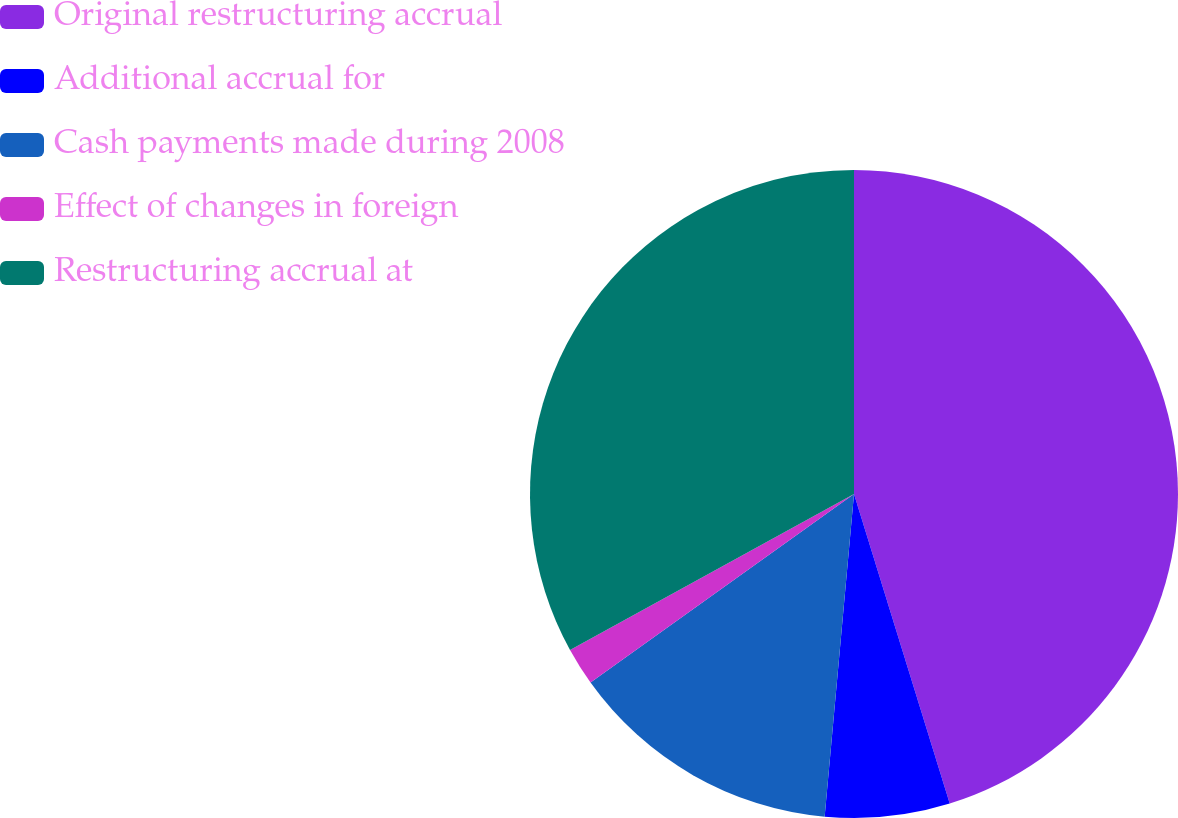Convert chart to OTSL. <chart><loc_0><loc_0><loc_500><loc_500><pie_chart><fcel>Original restructuring accrual<fcel>Additional accrual for<fcel>Cash payments made during 2008<fcel>Effect of changes in foreign<fcel>Restructuring accrual at<nl><fcel>45.23%<fcel>6.22%<fcel>13.67%<fcel>1.89%<fcel>33.0%<nl></chart> 